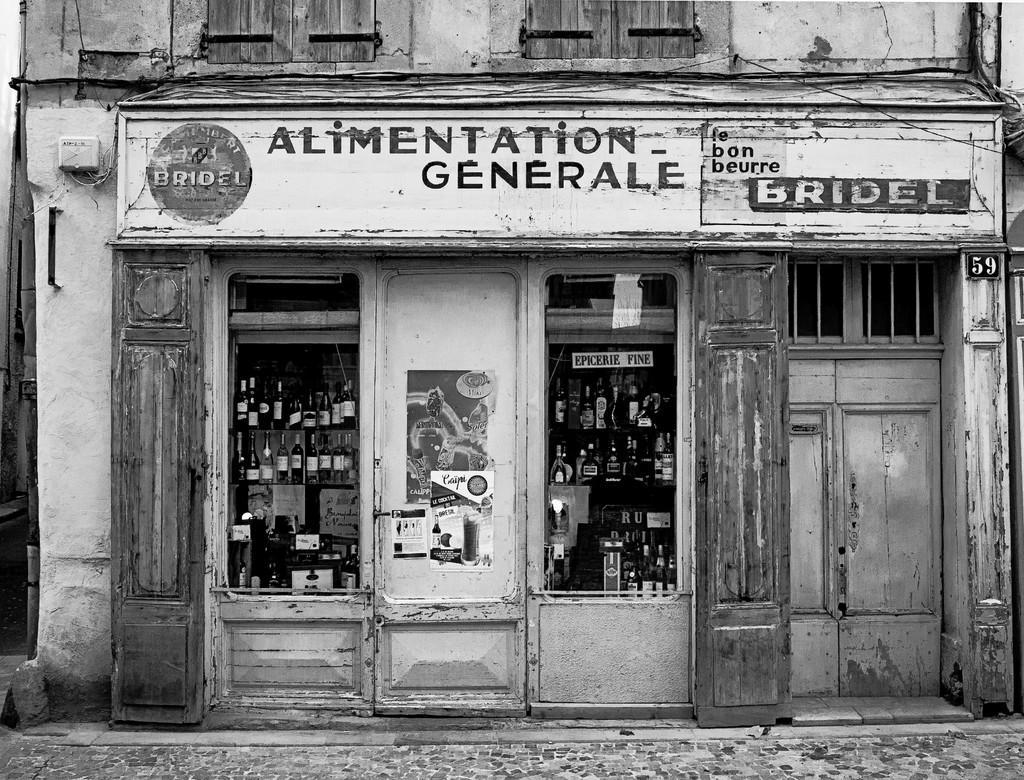Please provide a concise description of this image. There is a footpath. In the background, there are bottles arranged on the shelves, a hoarding, a door and there are windows of a building. 